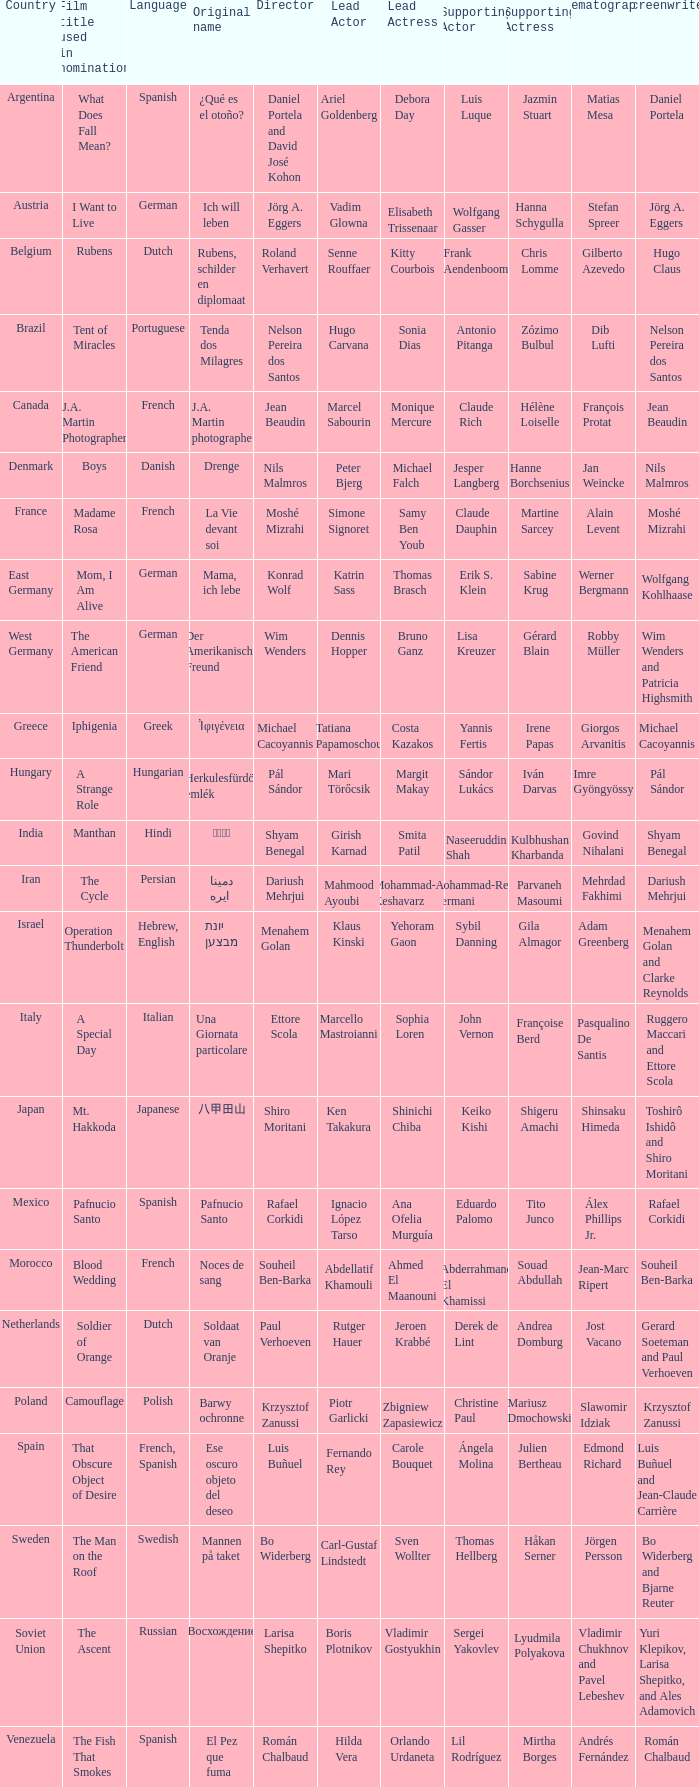Which country is the film Tent of Miracles from? Brazil. 